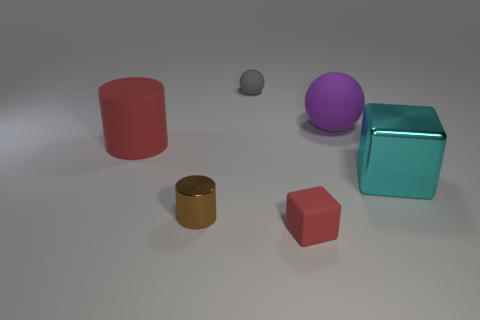Add 4 large green rubber spheres. How many objects exist? 10 Subtract all balls. How many objects are left? 4 Add 5 cyan blocks. How many cyan blocks exist? 6 Subtract 0 green cubes. How many objects are left? 6 Subtract all large cyan metallic objects. Subtract all red matte things. How many objects are left? 3 Add 5 brown cylinders. How many brown cylinders are left? 6 